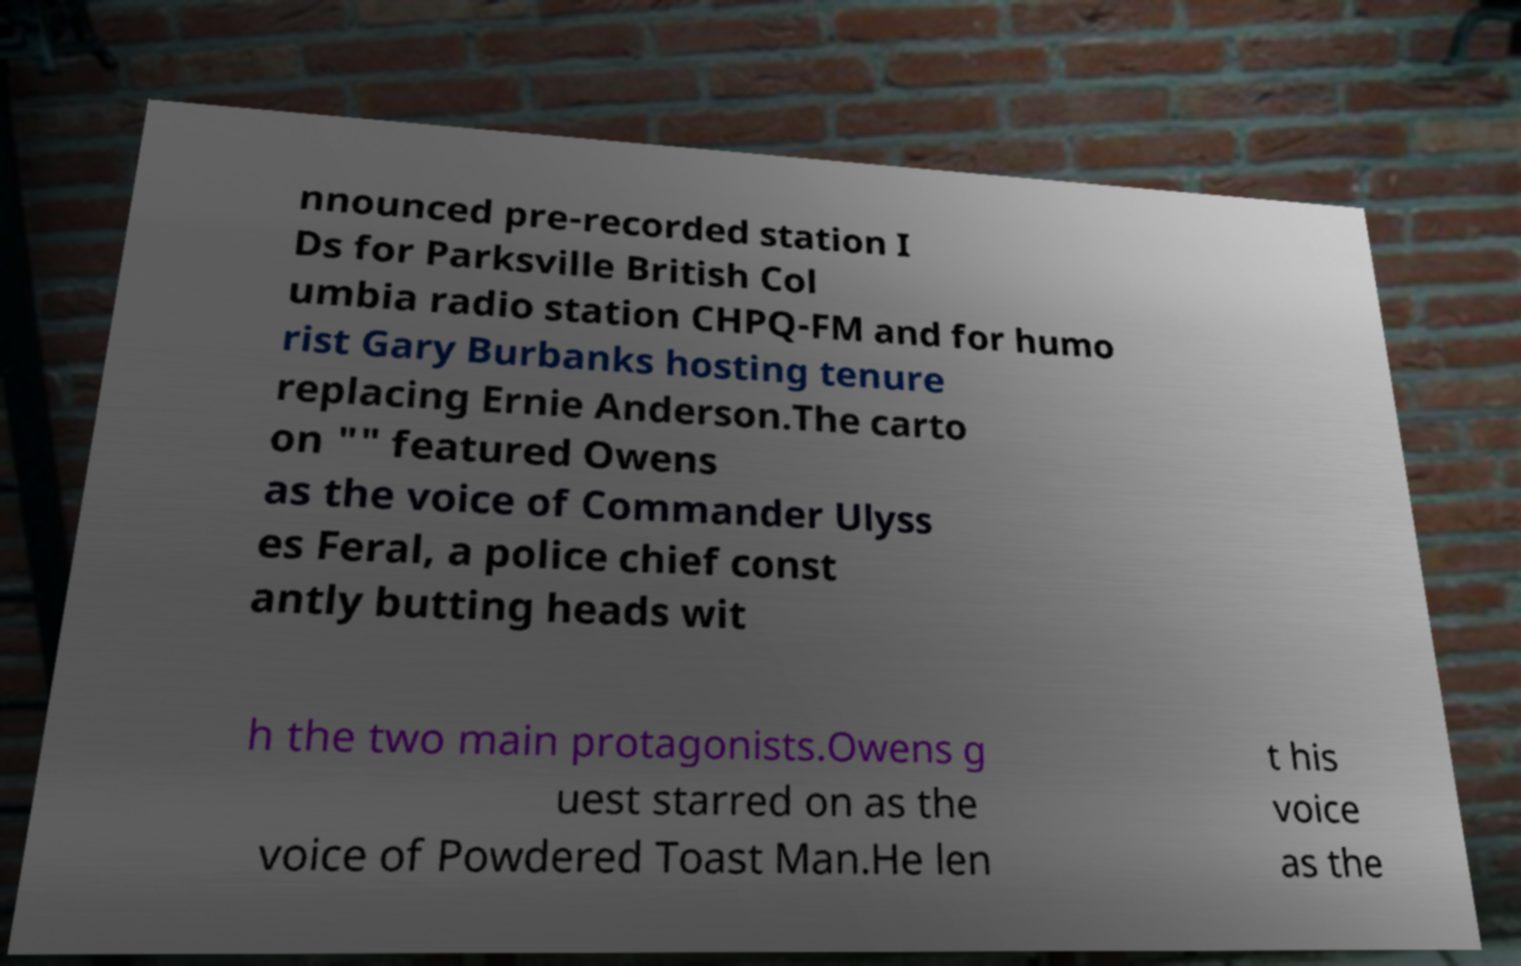There's text embedded in this image that I need extracted. Can you transcribe it verbatim? nnounced pre-recorded station I Ds for Parksville British Col umbia radio station CHPQ-FM and for humo rist Gary Burbanks hosting tenure replacing Ernie Anderson.The carto on "" featured Owens as the voice of Commander Ulyss es Feral, a police chief const antly butting heads wit h the two main protagonists.Owens g uest starred on as the voice of Powdered Toast Man.He len t his voice as the 